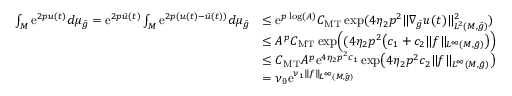Convert formula to latex. <formula><loc_0><loc_0><loc_500><loc_500>\begin{array} { r l } { \int _ { M } e ^ { 2 p u ( t ) } d \mu _ { \bar { g } } = e ^ { 2 p \bar { u } ( t ) } \int _ { M } e ^ { 2 p ( u ( t ) - \bar { u } ( t ) ) } d \mu _ { \bar { g } } } & { \leq e ^ { p \log ( A ) } C _ { M T } \exp ( 4 \eta _ { 2 } p ^ { 2 } \| \nabla _ { \bar { g } } u ( t ) \| _ { L ^ { 2 } ( M , \bar { g } ) } ^ { 2 } ) } \\ & { \leq A ^ { p } C _ { M T } \exp \left ( ( 4 \eta _ { 2 } p ^ { 2 } \left ( c _ { 1 } + c _ { 2 } \| f \| _ { L ^ { \infty } ( M , \bar { g } ) } \right ) \right ) } \\ & { \leq C _ { M T } A ^ { p } e ^ { 4 \eta _ { 2 } p ^ { 2 } c _ { 1 } } \exp \left ( 4 \eta _ { 2 } p ^ { 2 } c _ { 2 } \| f \| _ { L ^ { \infty } ( M , \bar { g } ) } \right ) } \\ & { = \nu _ { 0 } e ^ { \nu _ { 1 } \| f \| _ { L ^ { \infty } ( M , \bar { g } ) } } } \end{array}</formula> 